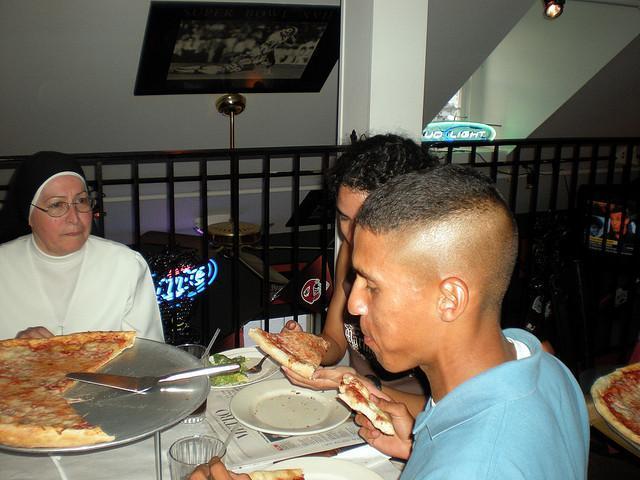How many pizzas have been taken from the pizza?
Give a very brief answer. 3. How many people are there?
Give a very brief answer. 3. How many pizzas can be seen?
Give a very brief answer. 3. 